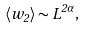Convert formula to latex. <formula><loc_0><loc_0><loc_500><loc_500>\langle w _ { 2 } \rangle \sim L ^ { 2 \alpha } ,</formula> 